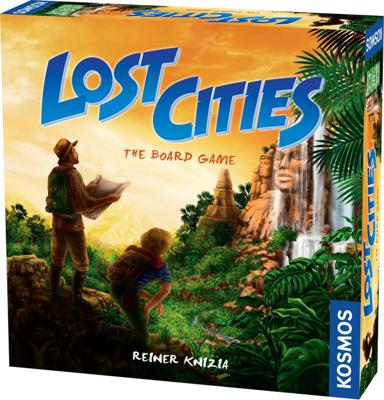Can you describe the gameplay of 'Lost Cities'? 'Lost Cities' is a card-based game where players use decks themed around five different exploration routes. Each player tries to strategically play their cards to advance their explorers along these routes, accumulating points by forming a series of ascending cards. The game challenges players to make risky decisions, often pushing their luck to maximize their scores. 